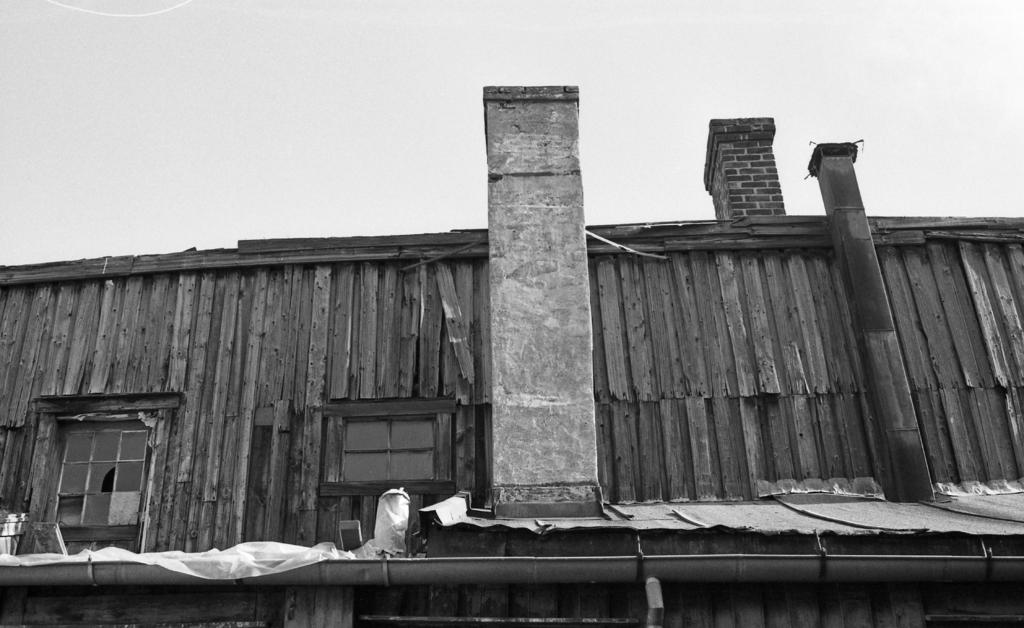What type of structure is in the picture? There is a house in the picture. What specific features does the house have? The house has windows and a roof. What other objects can be seen in the picture? There are other objects in the picture. What can be seen in the background of the picture? The sky is visible in the background of the picture. How is the picture presented in terms of color? The picture is black and white in color. What type of expansion can be seen happening to the house in the image? There is no expansion visible in the image. image. 